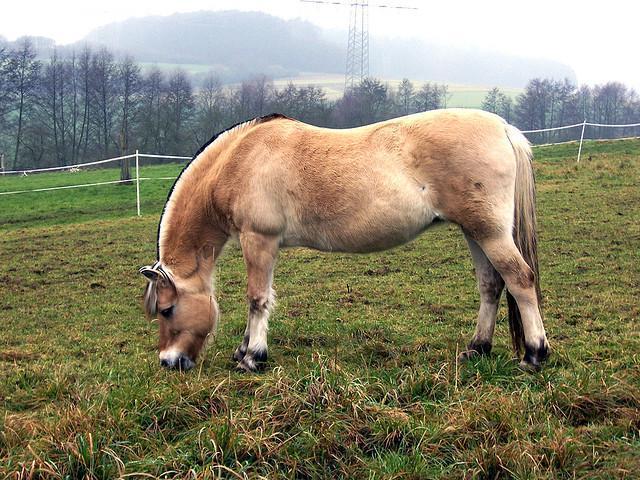How many animals?
Give a very brief answer. 1. 